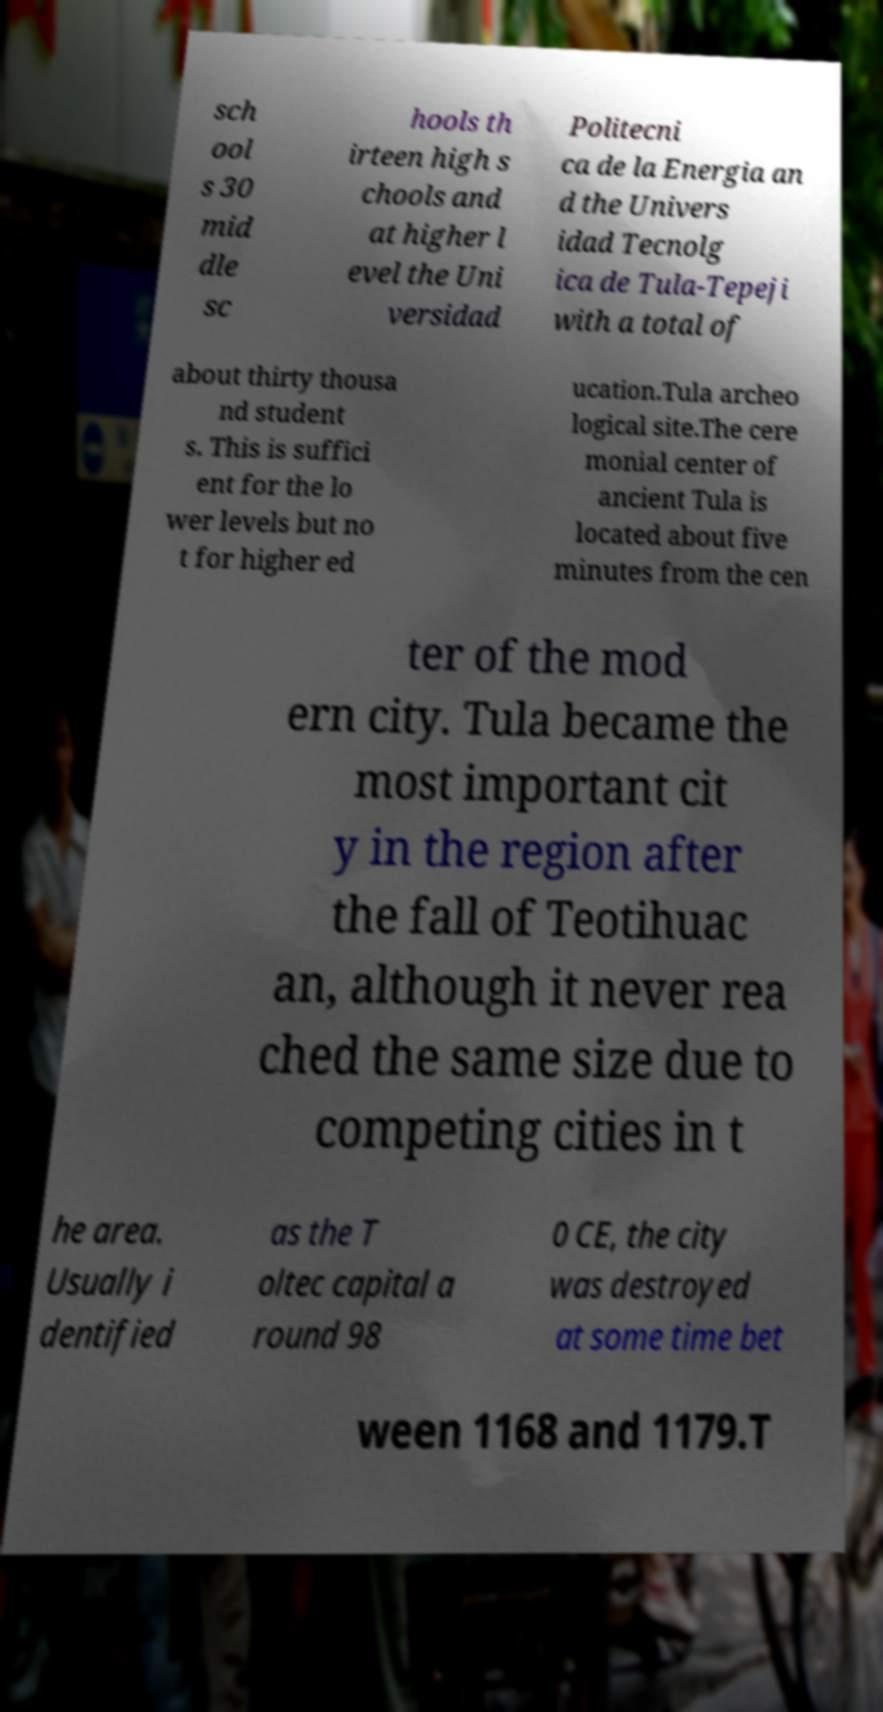There's text embedded in this image that I need extracted. Can you transcribe it verbatim? sch ool s 30 mid dle sc hools th irteen high s chools and at higher l evel the Uni versidad Politecni ca de la Energia an d the Univers idad Tecnolg ica de Tula-Tepeji with a total of about thirty thousa nd student s. This is suffici ent for the lo wer levels but no t for higher ed ucation.Tula archeo logical site.The cere monial center of ancient Tula is located about five minutes from the cen ter of the mod ern city. Tula became the most important cit y in the region after the fall of Teotihuac an, although it never rea ched the same size due to competing cities in t he area. Usually i dentified as the T oltec capital a round 98 0 CE, the city was destroyed at some time bet ween 1168 and 1179.T 